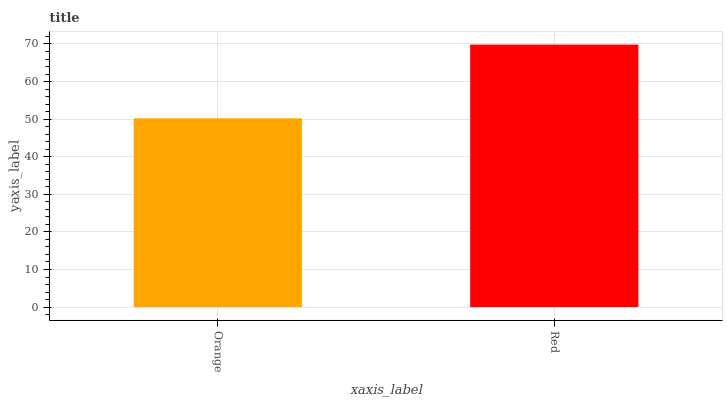Is Orange the minimum?
Answer yes or no. Yes. Is Red the maximum?
Answer yes or no. Yes. Is Red the minimum?
Answer yes or no. No. Is Red greater than Orange?
Answer yes or no. Yes. Is Orange less than Red?
Answer yes or no. Yes. Is Orange greater than Red?
Answer yes or no. No. Is Red less than Orange?
Answer yes or no. No. Is Red the high median?
Answer yes or no. Yes. Is Orange the low median?
Answer yes or no. Yes. Is Orange the high median?
Answer yes or no. No. Is Red the low median?
Answer yes or no. No. 